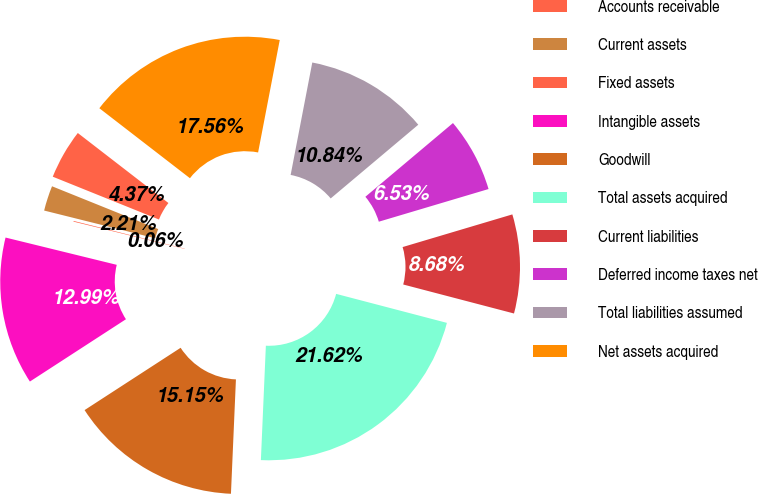Convert chart to OTSL. <chart><loc_0><loc_0><loc_500><loc_500><pie_chart><fcel>Accounts receivable<fcel>Current assets<fcel>Fixed assets<fcel>Intangible assets<fcel>Goodwill<fcel>Total assets acquired<fcel>Current liabilities<fcel>Deferred income taxes net<fcel>Total liabilities assumed<fcel>Net assets acquired<nl><fcel>4.37%<fcel>2.21%<fcel>0.06%<fcel>12.99%<fcel>15.15%<fcel>21.62%<fcel>8.68%<fcel>6.53%<fcel>10.84%<fcel>17.56%<nl></chart> 